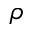<formula> <loc_0><loc_0><loc_500><loc_500>\rho</formula> 